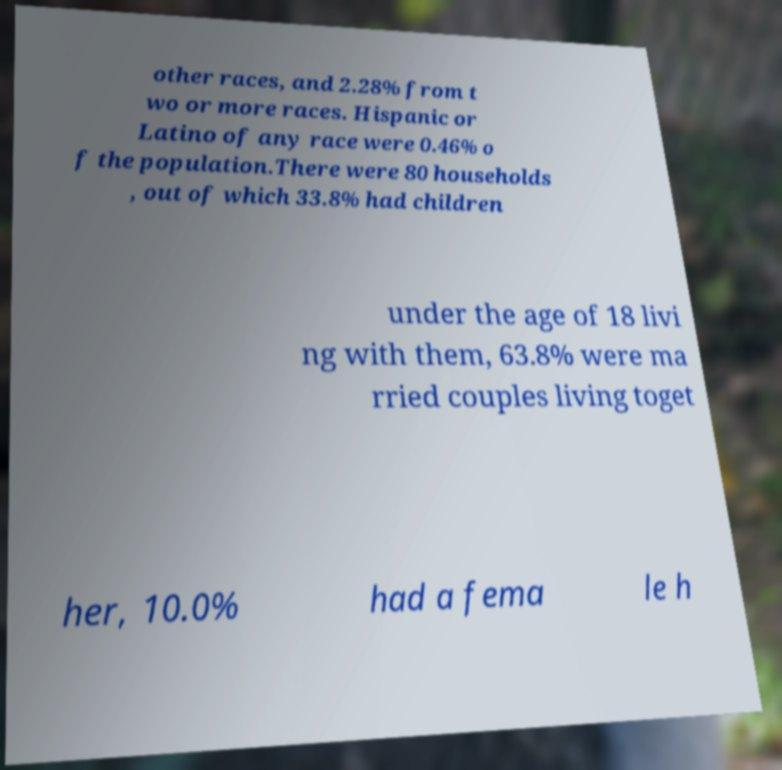Please identify and transcribe the text found in this image. other races, and 2.28% from t wo or more races. Hispanic or Latino of any race were 0.46% o f the population.There were 80 households , out of which 33.8% had children under the age of 18 livi ng with them, 63.8% were ma rried couples living toget her, 10.0% had a fema le h 